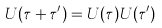Convert formula to latex. <formula><loc_0><loc_0><loc_500><loc_500>U ( \tau + \tau ^ { \prime } ) = U ( \tau ) U ( \tau ^ { \prime } )</formula> 